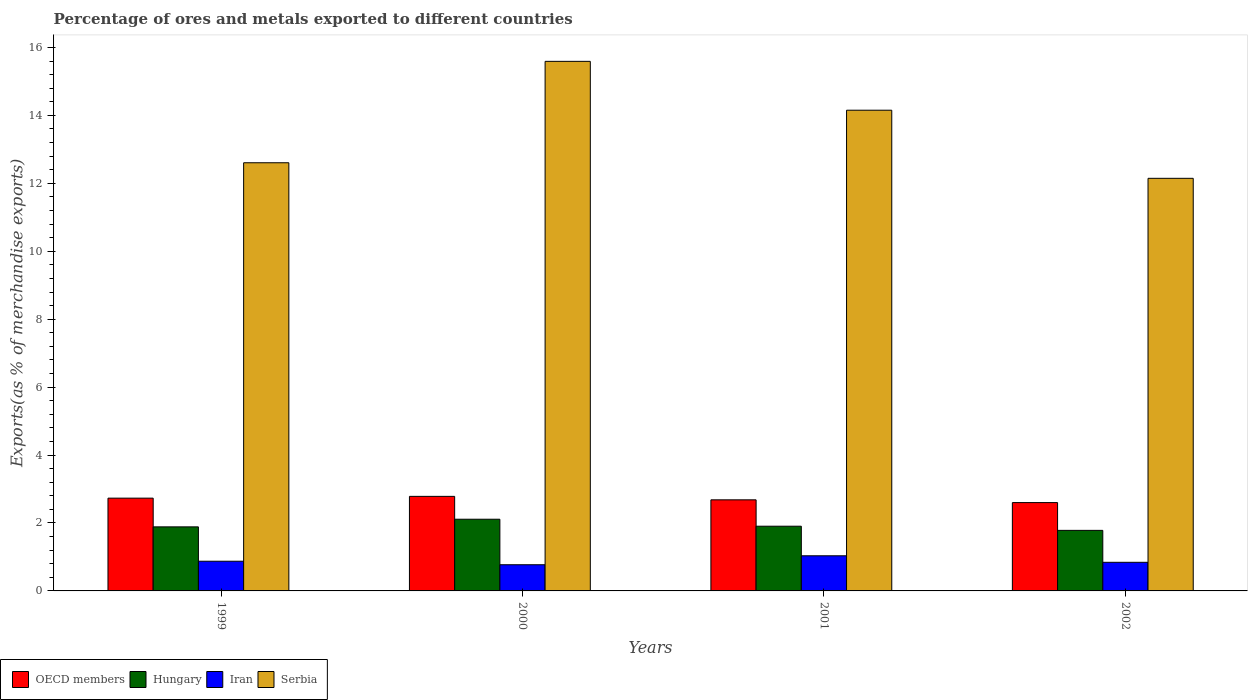How many different coloured bars are there?
Provide a succinct answer. 4. Are the number of bars on each tick of the X-axis equal?
Your answer should be compact. Yes. What is the label of the 2nd group of bars from the left?
Keep it short and to the point. 2000. What is the percentage of exports to different countries in Hungary in 2000?
Make the answer very short. 2.11. Across all years, what is the maximum percentage of exports to different countries in Hungary?
Offer a very short reply. 2.11. Across all years, what is the minimum percentage of exports to different countries in Iran?
Give a very brief answer. 0.77. In which year was the percentage of exports to different countries in Iran minimum?
Make the answer very short. 2000. What is the total percentage of exports to different countries in Iran in the graph?
Offer a terse response. 3.52. What is the difference between the percentage of exports to different countries in OECD members in 1999 and that in 2001?
Give a very brief answer. 0.05. What is the difference between the percentage of exports to different countries in Hungary in 2002 and the percentage of exports to different countries in Serbia in 1999?
Ensure brevity in your answer.  -10.82. What is the average percentage of exports to different countries in Iran per year?
Provide a short and direct response. 0.88. In the year 2002, what is the difference between the percentage of exports to different countries in OECD members and percentage of exports to different countries in Iran?
Offer a terse response. 1.76. What is the ratio of the percentage of exports to different countries in Hungary in 2001 to that in 2002?
Offer a terse response. 1.07. Is the percentage of exports to different countries in Serbia in 1999 less than that in 2002?
Offer a terse response. No. Is the difference between the percentage of exports to different countries in OECD members in 1999 and 2001 greater than the difference between the percentage of exports to different countries in Iran in 1999 and 2001?
Give a very brief answer. Yes. What is the difference between the highest and the second highest percentage of exports to different countries in Iran?
Provide a succinct answer. 0.16. What is the difference between the highest and the lowest percentage of exports to different countries in Hungary?
Ensure brevity in your answer.  0.33. Is it the case that in every year, the sum of the percentage of exports to different countries in Iran and percentage of exports to different countries in Serbia is greater than the sum of percentage of exports to different countries in Hungary and percentage of exports to different countries in OECD members?
Your answer should be very brief. Yes. What does the 3rd bar from the left in 1999 represents?
Keep it short and to the point. Iran. What does the 4th bar from the right in 2001 represents?
Make the answer very short. OECD members. Is it the case that in every year, the sum of the percentage of exports to different countries in OECD members and percentage of exports to different countries in Hungary is greater than the percentage of exports to different countries in Serbia?
Offer a terse response. No. How many bars are there?
Your answer should be compact. 16. What is the difference between two consecutive major ticks on the Y-axis?
Your answer should be compact. 2. Does the graph contain any zero values?
Provide a short and direct response. No. How are the legend labels stacked?
Offer a terse response. Horizontal. What is the title of the graph?
Offer a very short reply. Percentage of ores and metals exported to different countries. Does "Jamaica" appear as one of the legend labels in the graph?
Ensure brevity in your answer.  No. What is the label or title of the X-axis?
Your answer should be very brief. Years. What is the label or title of the Y-axis?
Give a very brief answer. Exports(as % of merchandise exports). What is the Exports(as % of merchandise exports) of OECD members in 1999?
Make the answer very short. 2.73. What is the Exports(as % of merchandise exports) in Hungary in 1999?
Ensure brevity in your answer.  1.89. What is the Exports(as % of merchandise exports) of Iran in 1999?
Your answer should be very brief. 0.87. What is the Exports(as % of merchandise exports) in Serbia in 1999?
Give a very brief answer. 12.61. What is the Exports(as % of merchandise exports) in OECD members in 2000?
Provide a short and direct response. 2.78. What is the Exports(as % of merchandise exports) in Hungary in 2000?
Offer a terse response. 2.11. What is the Exports(as % of merchandise exports) in Iran in 2000?
Give a very brief answer. 0.77. What is the Exports(as % of merchandise exports) of Serbia in 2000?
Offer a very short reply. 15.59. What is the Exports(as % of merchandise exports) of OECD members in 2001?
Your answer should be compact. 2.68. What is the Exports(as % of merchandise exports) of Hungary in 2001?
Keep it short and to the point. 1.91. What is the Exports(as % of merchandise exports) in Iran in 2001?
Provide a succinct answer. 1.03. What is the Exports(as % of merchandise exports) of Serbia in 2001?
Keep it short and to the point. 14.15. What is the Exports(as % of merchandise exports) in OECD members in 2002?
Keep it short and to the point. 2.6. What is the Exports(as % of merchandise exports) in Hungary in 2002?
Your answer should be very brief. 1.78. What is the Exports(as % of merchandise exports) of Iran in 2002?
Make the answer very short. 0.84. What is the Exports(as % of merchandise exports) of Serbia in 2002?
Make the answer very short. 12.15. Across all years, what is the maximum Exports(as % of merchandise exports) in OECD members?
Provide a succinct answer. 2.78. Across all years, what is the maximum Exports(as % of merchandise exports) in Hungary?
Keep it short and to the point. 2.11. Across all years, what is the maximum Exports(as % of merchandise exports) in Iran?
Offer a terse response. 1.03. Across all years, what is the maximum Exports(as % of merchandise exports) in Serbia?
Offer a very short reply. 15.59. Across all years, what is the minimum Exports(as % of merchandise exports) of OECD members?
Your answer should be compact. 2.6. Across all years, what is the minimum Exports(as % of merchandise exports) in Hungary?
Your answer should be very brief. 1.78. Across all years, what is the minimum Exports(as % of merchandise exports) of Iran?
Give a very brief answer. 0.77. Across all years, what is the minimum Exports(as % of merchandise exports) of Serbia?
Provide a short and direct response. 12.15. What is the total Exports(as % of merchandise exports) of OECD members in the graph?
Your response must be concise. 10.8. What is the total Exports(as % of merchandise exports) in Hungary in the graph?
Offer a terse response. 7.69. What is the total Exports(as % of merchandise exports) of Iran in the graph?
Keep it short and to the point. 3.52. What is the total Exports(as % of merchandise exports) of Serbia in the graph?
Offer a very short reply. 54.5. What is the difference between the Exports(as % of merchandise exports) of OECD members in 1999 and that in 2000?
Make the answer very short. -0.05. What is the difference between the Exports(as % of merchandise exports) of Hungary in 1999 and that in 2000?
Your answer should be very brief. -0.23. What is the difference between the Exports(as % of merchandise exports) of Iran in 1999 and that in 2000?
Offer a very short reply. 0.1. What is the difference between the Exports(as % of merchandise exports) in Serbia in 1999 and that in 2000?
Ensure brevity in your answer.  -2.99. What is the difference between the Exports(as % of merchandise exports) in OECD members in 1999 and that in 2001?
Your response must be concise. 0.05. What is the difference between the Exports(as % of merchandise exports) in Hungary in 1999 and that in 2001?
Make the answer very short. -0.02. What is the difference between the Exports(as % of merchandise exports) of Iran in 1999 and that in 2001?
Your answer should be compact. -0.16. What is the difference between the Exports(as % of merchandise exports) of Serbia in 1999 and that in 2001?
Ensure brevity in your answer.  -1.55. What is the difference between the Exports(as % of merchandise exports) in OECD members in 1999 and that in 2002?
Ensure brevity in your answer.  0.13. What is the difference between the Exports(as % of merchandise exports) of Hungary in 1999 and that in 2002?
Your answer should be compact. 0.1. What is the difference between the Exports(as % of merchandise exports) of Iran in 1999 and that in 2002?
Your answer should be compact. 0.03. What is the difference between the Exports(as % of merchandise exports) in Serbia in 1999 and that in 2002?
Provide a succinct answer. 0.46. What is the difference between the Exports(as % of merchandise exports) in OECD members in 2000 and that in 2001?
Your answer should be very brief. 0.1. What is the difference between the Exports(as % of merchandise exports) in Hungary in 2000 and that in 2001?
Keep it short and to the point. 0.21. What is the difference between the Exports(as % of merchandise exports) of Iran in 2000 and that in 2001?
Your response must be concise. -0.26. What is the difference between the Exports(as % of merchandise exports) in Serbia in 2000 and that in 2001?
Your answer should be compact. 1.44. What is the difference between the Exports(as % of merchandise exports) in OECD members in 2000 and that in 2002?
Your answer should be compact. 0.18. What is the difference between the Exports(as % of merchandise exports) in Hungary in 2000 and that in 2002?
Offer a terse response. 0.33. What is the difference between the Exports(as % of merchandise exports) of Iran in 2000 and that in 2002?
Your response must be concise. -0.07. What is the difference between the Exports(as % of merchandise exports) in Serbia in 2000 and that in 2002?
Your answer should be compact. 3.44. What is the difference between the Exports(as % of merchandise exports) in OECD members in 2001 and that in 2002?
Your answer should be compact. 0.08. What is the difference between the Exports(as % of merchandise exports) in Hungary in 2001 and that in 2002?
Offer a terse response. 0.12. What is the difference between the Exports(as % of merchandise exports) in Iran in 2001 and that in 2002?
Ensure brevity in your answer.  0.19. What is the difference between the Exports(as % of merchandise exports) of Serbia in 2001 and that in 2002?
Ensure brevity in your answer.  2.01. What is the difference between the Exports(as % of merchandise exports) of OECD members in 1999 and the Exports(as % of merchandise exports) of Hungary in 2000?
Make the answer very short. 0.62. What is the difference between the Exports(as % of merchandise exports) of OECD members in 1999 and the Exports(as % of merchandise exports) of Iran in 2000?
Provide a succinct answer. 1.96. What is the difference between the Exports(as % of merchandise exports) in OECD members in 1999 and the Exports(as % of merchandise exports) in Serbia in 2000?
Your response must be concise. -12.86. What is the difference between the Exports(as % of merchandise exports) of Hungary in 1999 and the Exports(as % of merchandise exports) of Iran in 2000?
Keep it short and to the point. 1.12. What is the difference between the Exports(as % of merchandise exports) in Hungary in 1999 and the Exports(as % of merchandise exports) in Serbia in 2000?
Offer a very short reply. -13.71. What is the difference between the Exports(as % of merchandise exports) of Iran in 1999 and the Exports(as % of merchandise exports) of Serbia in 2000?
Your answer should be very brief. -14.72. What is the difference between the Exports(as % of merchandise exports) of OECD members in 1999 and the Exports(as % of merchandise exports) of Hungary in 2001?
Make the answer very short. 0.83. What is the difference between the Exports(as % of merchandise exports) in OECD members in 1999 and the Exports(as % of merchandise exports) in Iran in 2001?
Give a very brief answer. 1.7. What is the difference between the Exports(as % of merchandise exports) in OECD members in 1999 and the Exports(as % of merchandise exports) in Serbia in 2001?
Provide a short and direct response. -11.42. What is the difference between the Exports(as % of merchandise exports) in Hungary in 1999 and the Exports(as % of merchandise exports) in Iran in 2001?
Keep it short and to the point. 0.85. What is the difference between the Exports(as % of merchandise exports) of Hungary in 1999 and the Exports(as % of merchandise exports) of Serbia in 2001?
Your answer should be compact. -12.27. What is the difference between the Exports(as % of merchandise exports) in Iran in 1999 and the Exports(as % of merchandise exports) in Serbia in 2001?
Keep it short and to the point. -13.28. What is the difference between the Exports(as % of merchandise exports) in OECD members in 1999 and the Exports(as % of merchandise exports) in Hungary in 2002?
Give a very brief answer. 0.95. What is the difference between the Exports(as % of merchandise exports) of OECD members in 1999 and the Exports(as % of merchandise exports) of Iran in 2002?
Give a very brief answer. 1.89. What is the difference between the Exports(as % of merchandise exports) in OECD members in 1999 and the Exports(as % of merchandise exports) in Serbia in 2002?
Ensure brevity in your answer.  -9.42. What is the difference between the Exports(as % of merchandise exports) of Hungary in 1999 and the Exports(as % of merchandise exports) of Iran in 2002?
Provide a short and direct response. 1.04. What is the difference between the Exports(as % of merchandise exports) of Hungary in 1999 and the Exports(as % of merchandise exports) of Serbia in 2002?
Your answer should be very brief. -10.26. What is the difference between the Exports(as % of merchandise exports) in Iran in 1999 and the Exports(as % of merchandise exports) in Serbia in 2002?
Your answer should be very brief. -11.27. What is the difference between the Exports(as % of merchandise exports) in OECD members in 2000 and the Exports(as % of merchandise exports) in Hungary in 2001?
Your response must be concise. 0.88. What is the difference between the Exports(as % of merchandise exports) of OECD members in 2000 and the Exports(as % of merchandise exports) of Iran in 2001?
Give a very brief answer. 1.75. What is the difference between the Exports(as % of merchandise exports) in OECD members in 2000 and the Exports(as % of merchandise exports) in Serbia in 2001?
Provide a short and direct response. -11.37. What is the difference between the Exports(as % of merchandise exports) of Hungary in 2000 and the Exports(as % of merchandise exports) of Iran in 2001?
Keep it short and to the point. 1.08. What is the difference between the Exports(as % of merchandise exports) in Hungary in 2000 and the Exports(as % of merchandise exports) in Serbia in 2001?
Offer a very short reply. -12.04. What is the difference between the Exports(as % of merchandise exports) in Iran in 2000 and the Exports(as % of merchandise exports) in Serbia in 2001?
Offer a terse response. -13.38. What is the difference between the Exports(as % of merchandise exports) of OECD members in 2000 and the Exports(as % of merchandise exports) of Iran in 2002?
Give a very brief answer. 1.94. What is the difference between the Exports(as % of merchandise exports) in OECD members in 2000 and the Exports(as % of merchandise exports) in Serbia in 2002?
Make the answer very short. -9.36. What is the difference between the Exports(as % of merchandise exports) of Hungary in 2000 and the Exports(as % of merchandise exports) of Iran in 2002?
Give a very brief answer. 1.27. What is the difference between the Exports(as % of merchandise exports) of Hungary in 2000 and the Exports(as % of merchandise exports) of Serbia in 2002?
Your answer should be very brief. -10.04. What is the difference between the Exports(as % of merchandise exports) in Iran in 2000 and the Exports(as % of merchandise exports) in Serbia in 2002?
Provide a succinct answer. -11.38. What is the difference between the Exports(as % of merchandise exports) in OECD members in 2001 and the Exports(as % of merchandise exports) in Hungary in 2002?
Your response must be concise. 0.9. What is the difference between the Exports(as % of merchandise exports) of OECD members in 2001 and the Exports(as % of merchandise exports) of Iran in 2002?
Your answer should be compact. 1.84. What is the difference between the Exports(as % of merchandise exports) in OECD members in 2001 and the Exports(as % of merchandise exports) in Serbia in 2002?
Give a very brief answer. -9.47. What is the difference between the Exports(as % of merchandise exports) of Hungary in 2001 and the Exports(as % of merchandise exports) of Iran in 2002?
Keep it short and to the point. 1.06. What is the difference between the Exports(as % of merchandise exports) in Hungary in 2001 and the Exports(as % of merchandise exports) in Serbia in 2002?
Give a very brief answer. -10.24. What is the difference between the Exports(as % of merchandise exports) in Iran in 2001 and the Exports(as % of merchandise exports) in Serbia in 2002?
Your answer should be very brief. -11.11. What is the average Exports(as % of merchandise exports) of OECD members per year?
Give a very brief answer. 2.7. What is the average Exports(as % of merchandise exports) of Hungary per year?
Provide a succinct answer. 1.92. What is the average Exports(as % of merchandise exports) of Iran per year?
Offer a terse response. 0.88. What is the average Exports(as % of merchandise exports) in Serbia per year?
Provide a succinct answer. 13.62. In the year 1999, what is the difference between the Exports(as % of merchandise exports) in OECD members and Exports(as % of merchandise exports) in Hungary?
Provide a short and direct response. 0.85. In the year 1999, what is the difference between the Exports(as % of merchandise exports) of OECD members and Exports(as % of merchandise exports) of Iran?
Keep it short and to the point. 1.86. In the year 1999, what is the difference between the Exports(as % of merchandise exports) in OECD members and Exports(as % of merchandise exports) in Serbia?
Your answer should be compact. -9.87. In the year 1999, what is the difference between the Exports(as % of merchandise exports) in Hungary and Exports(as % of merchandise exports) in Iran?
Your answer should be very brief. 1.01. In the year 1999, what is the difference between the Exports(as % of merchandise exports) of Hungary and Exports(as % of merchandise exports) of Serbia?
Keep it short and to the point. -10.72. In the year 1999, what is the difference between the Exports(as % of merchandise exports) in Iran and Exports(as % of merchandise exports) in Serbia?
Offer a terse response. -11.73. In the year 2000, what is the difference between the Exports(as % of merchandise exports) in OECD members and Exports(as % of merchandise exports) in Hungary?
Your response must be concise. 0.67. In the year 2000, what is the difference between the Exports(as % of merchandise exports) of OECD members and Exports(as % of merchandise exports) of Iran?
Your response must be concise. 2.01. In the year 2000, what is the difference between the Exports(as % of merchandise exports) of OECD members and Exports(as % of merchandise exports) of Serbia?
Your answer should be compact. -12.81. In the year 2000, what is the difference between the Exports(as % of merchandise exports) of Hungary and Exports(as % of merchandise exports) of Iran?
Offer a very short reply. 1.34. In the year 2000, what is the difference between the Exports(as % of merchandise exports) of Hungary and Exports(as % of merchandise exports) of Serbia?
Your answer should be very brief. -13.48. In the year 2000, what is the difference between the Exports(as % of merchandise exports) of Iran and Exports(as % of merchandise exports) of Serbia?
Offer a very short reply. -14.82. In the year 2001, what is the difference between the Exports(as % of merchandise exports) of OECD members and Exports(as % of merchandise exports) of Hungary?
Provide a succinct answer. 0.78. In the year 2001, what is the difference between the Exports(as % of merchandise exports) in OECD members and Exports(as % of merchandise exports) in Iran?
Your answer should be compact. 1.65. In the year 2001, what is the difference between the Exports(as % of merchandise exports) of OECD members and Exports(as % of merchandise exports) of Serbia?
Your response must be concise. -11.47. In the year 2001, what is the difference between the Exports(as % of merchandise exports) in Hungary and Exports(as % of merchandise exports) in Iran?
Offer a very short reply. 0.87. In the year 2001, what is the difference between the Exports(as % of merchandise exports) of Hungary and Exports(as % of merchandise exports) of Serbia?
Ensure brevity in your answer.  -12.25. In the year 2001, what is the difference between the Exports(as % of merchandise exports) of Iran and Exports(as % of merchandise exports) of Serbia?
Keep it short and to the point. -13.12. In the year 2002, what is the difference between the Exports(as % of merchandise exports) in OECD members and Exports(as % of merchandise exports) in Hungary?
Offer a terse response. 0.82. In the year 2002, what is the difference between the Exports(as % of merchandise exports) in OECD members and Exports(as % of merchandise exports) in Iran?
Ensure brevity in your answer.  1.76. In the year 2002, what is the difference between the Exports(as % of merchandise exports) in OECD members and Exports(as % of merchandise exports) in Serbia?
Provide a short and direct response. -9.55. In the year 2002, what is the difference between the Exports(as % of merchandise exports) of Hungary and Exports(as % of merchandise exports) of Iran?
Your answer should be very brief. 0.94. In the year 2002, what is the difference between the Exports(as % of merchandise exports) of Hungary and Exports(as % of merchandise exports) of Serbia?
Ensure brevity in your answer.  -10.36. In the year 2002, what is the difference between the Exports(as % of merchandise exports) in Iran and Exports(as % of merchandise exports) in Serbia?
Provide a short and direct response. -11.31. What is the ratio of the Exports(as % of merchandise exports) of OECD members in 1999 to that in 2000?
Offer a very short reply. 0.98. What is the ratio of the Exports(as % of merchandise exports) in Hungary in 1999 to that in 2000?
Your answer should be very brief. 0.89. What is the ratio of the Exports(as % of merchandise exports) of Iran in 1999 to that in 2000?
Make the answer very short. 1.13. What is the ratio of the Exports(as % of merchandise exports) in Serbia in 1999 to that in 2000?
Offer a very short reply. 0.81. What is the ratio of the Exports(as % of merchandise exports) in OECD members in 1999 to that in 2001?
Make the answer very short. 1.02. What is the ratio of the Exports(as % of merchandise exports) in Hungary in 1999 to that in 2001?
Offer a very short reply. 0.99. What is the ratio of the Exports(as % of merchandise exports) in Iran in 1999 to that in 2001?
Give a very brief answer. 0.85. What is the ratio of the Exports(as % of merchandise exports) of Serbia in 1999 to that in 2001?
Offer a very short reply. 0.89. What is the ratio of the Exports(as % of merchandise exports) in OECD members in 1999 to that in 2002?
Keep it short and to the point. 1.05. What is the ratio of the Exports(as % of merchandise exports) of Hungary in 1999 to that in 2002?
Make the answer very short. 1.06. What is the ratio of the Exports(as % of merchandise exports) of Iran in 1999 to that in 2002?
Keep it short and to the point. 1.04. What is the ratio of the Exports(as % of merchandise exports) of Serbia in 1999 to that in 2002?
Provide a succinct answer. 1.04. What is the ratio of the Exports(as % of merchandise exports) of OECD members in 2000 to that in 2001?
Your answer should be very brief. 1.04. What is the ratio of the Exports(as % of merchandise exports) of Hungary in 2000 to that in 2001?
Keep it short and to the point. 1.11. What is the ratio of the Exports(as % of merchandise exports) in Iran in 2000 to that in 2001?
Provide a succinct answer. 0.75. What is the ratio of the Exports(as % of merchandise exports) in Serbia in 2000 to that in 2001?
Your answer should be compact. 1.1. What is the ratio of the Exports(as % of merchandise exports) of OECD members in 2000 to that in 2002?
Offer a very short reply. 1.07. What is the ratio of the Exports(as % of merchandise exports) in Hungary in 2000 to that in 2002?
Provide a succinct answer. 1.18. What is the ratio of the Exports(as % of merchandise exports) in Iran in 2000 to that in 2002?
Your response must be concise. 0.91. What is the ratio of the Exports(as % of merchandise exports) of Serbia in 2000 to that in 2002?
Offer a very short reply. 1.28. What is the ratio of the Exports(as % of merchandise exports) in OECD members in 2001 to that in 2002?
Your answer should be compact. 1.03. What is the ratio of the Exports(as % of merchandise exports) in Hungary in 2001 to that in 2002?
Provide a short and direct response. 1.07. What is the ratio of the Exports(as % of merchandise exports) in Iran in 2001 to that in 2002?
Offer a terse response. 1.23. What is the ratio of the Exports(as % of merchandise exports) of Serbia in 2001 to that in 2002?
Your answer should be very brief. 1.17. What is the difference between the highest and the second highest Exports(as % of merchandise exports) in OECD members?
Make the answer very short. 0.05. What is the difference between the highest and the second highest Exports(as % of merchandise exports) in Hungary?
Your response must be concise. 0.21. What is the difference between the highest and the second highest Exports(as % of merchandise exports) of Iran?
Your answer should be compact. 0.16. What is the difference between the highest and the second highest Exports(as % of merchandise exports) in Serbia?
Ensure brevity in your answer.  1.44. What is the difference between the highest and the lowest Exports(as % of merchandise exports) in OECD members?
Offer a terse response. 0.18. What is the difference between the highest and the lowest Exports(as % of merchandise exports) of Hungary?
Your answer should be very brief. 0.33. What is the difference between the highest and the lowest Exports(as % of merchandise exports) in Iran?
Give a very brief answer. 0.26. What is the difference between the highest and the lowest Exports(as % of merchandise exports) of Serbia?
Your answer should be very brief. 3.44. 